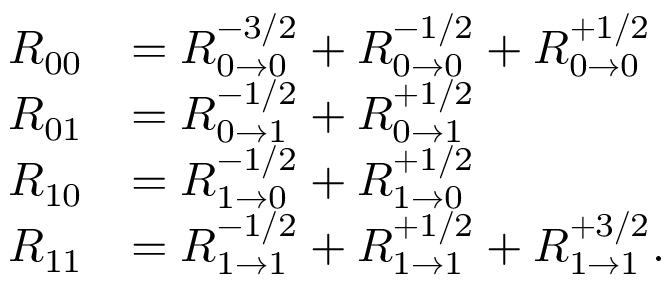Convert formula to latex. <formula><loc_0><loc_0><loc_500><loc_500>\begin{array} { r l } { R _ { 0 0 } } & { = R _ { 0 \rightarrow 0 } ^ { - 3 / 2 } + R _ { 0 \rightarrow 0 } ^ { - 1 / 2 } + R _ { 0 \rightarrow 0 } ^ { + 1 / 2 } } \\ { R _ { 0 1 } } & { = R _ { 0 \rightarrow 1 } ^ { - 1 / 2 } + R _ { 0 \rightarrow 1 } ^ { + 1 / 2 } } \\ { R _ { 1 0 } } & { = R _ { 1 \rightarrow 0 } ^ { - 1 / 2 } + R _ { 1 \rightarrow 0 } ^ { + 1 / 2 } } \\ { R _ { 1 1 } } & { = R _ { 1 \rightarrow 1 } ^ { - 1 / 2 } + R _ { 1 \rightarrow 1 } ^ { + 1 / 2 } + R _ { 1 \rightarrow 1 } ^ { + 3 / 2 } . } \end{array}</formula> 